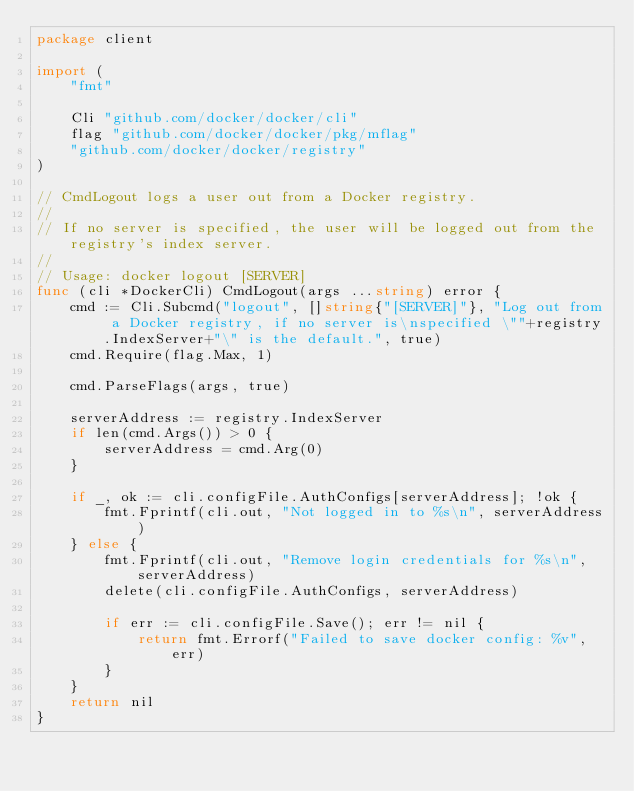<code> <loc_0><loc_0><loc_500><loc_500><_Go_>package client

import (
	"fmt"

	Cli "github.com/docker/docker/cli"
	flag "github.com/docker/docker/pkg/mflag"
	"github.com/docker/docker/registry"
)

// CmdLogout logs a user out from a Docker registry.
//
// If no server is specified, the user will be logged out from the registry's index server.
//
// Usage: docker logout [SERVER]
func (cli *DockerCli) CmdLogout(args ...string) error {
	cmd := Cli.Subcmd("logout", []string{"[SERVER]"}, "Log out from a Docker registry, if no server is\nspecified \""+registry.IndexServer+"\" is the default.", true)
	cmd.Require(flag.Max, 1)

	cmd.ParseFlags(args, true)

	serverAddress := registry.IndexServer
	if len(cmd.Args()) > 0 {
		serverAddress = cmd.Arg(0)
	}

	if _, ok := cli.configFile.AuthConfigs[serverAddress]; !ok {
		fmt.Fprintf(cli.out, "Not logged in to %s\n", serverAddress)
	} else {
		fmt.Fprintf(cli.out, "Remove login credentials for %s\n", serverAddress)
		delete(cli.configFile.AuthConfigs, serverAddress)

		if err := cli.configFile.Save(); err != nil {
			return fmt.Errorf("Failed to save docker config: %v", err)
		}
	}
	return nil
}
</code> 